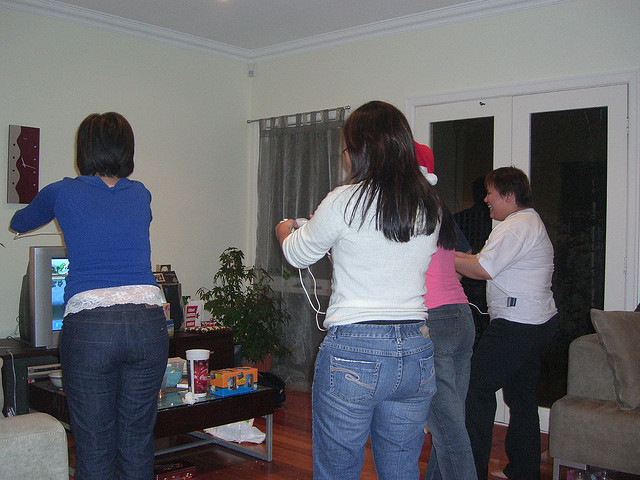What are the people in the image doing? The individuals are gathered around a television and seem to be playing a motion-controlled video game, participating energetically in the digital entertainment. 